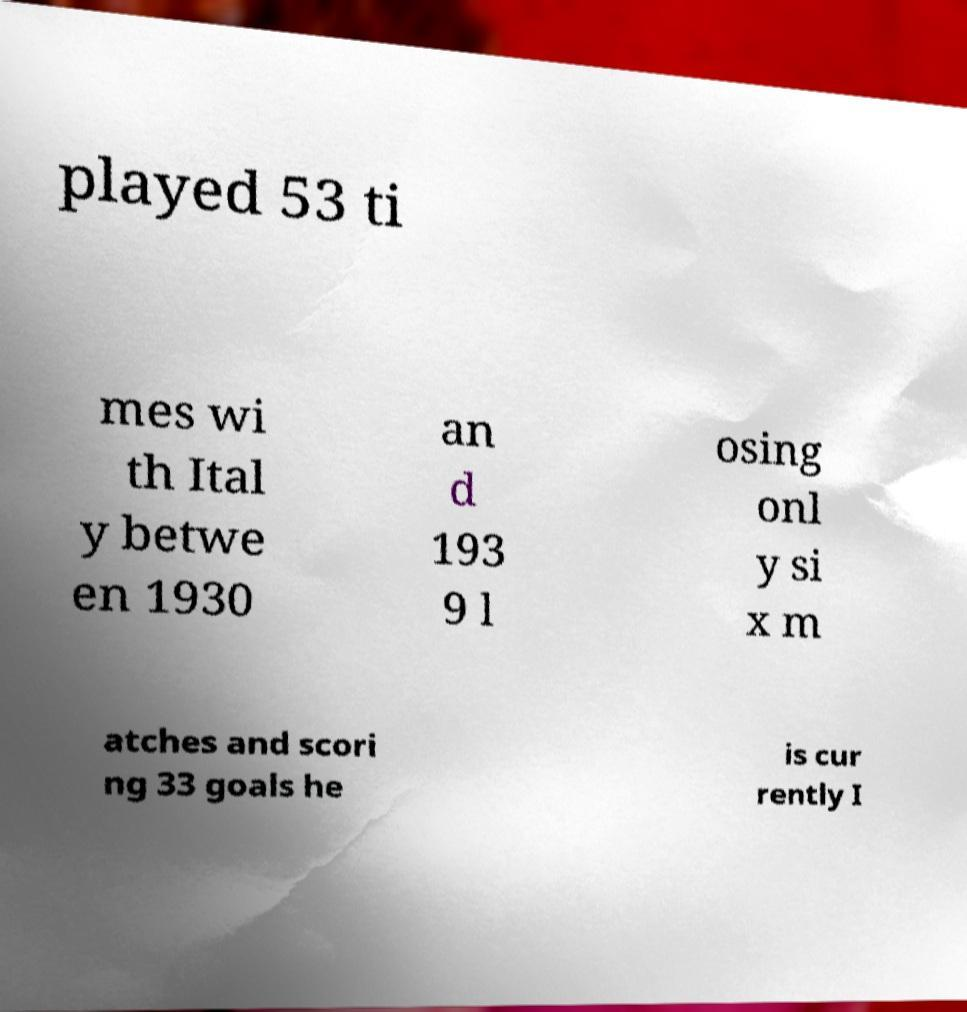Please read and relay the text visible in this image. What does it say? played 53 ti mes wi th Ital y betwe en 1930 an d 193 9 l osing onl y si x m atches and scori ng 33 goals he is cur rently I 